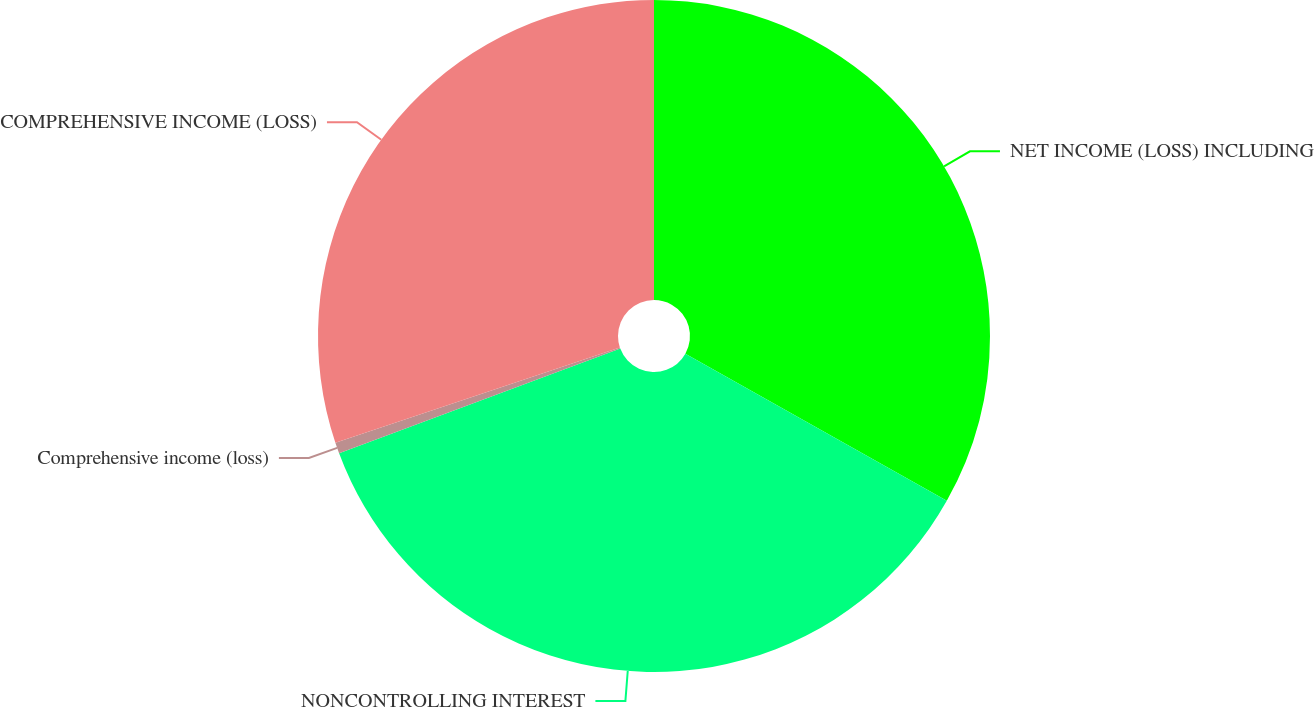Convert chart. <chart><loc_0><loc_0><loc_500><loc_500><pie_chart><fcel>NET INCOME (LOSS) INCLUDING<fcel>NONCONTROLLING INTEREST<fcel>Comprehensive income (loss)<fcel>COMPREHENSIVE INCOME (LOSS)<nl><fcel>33.16%<fcel>36.17%<fcel>0.53%<fcel>30.14%<nl></chart> 